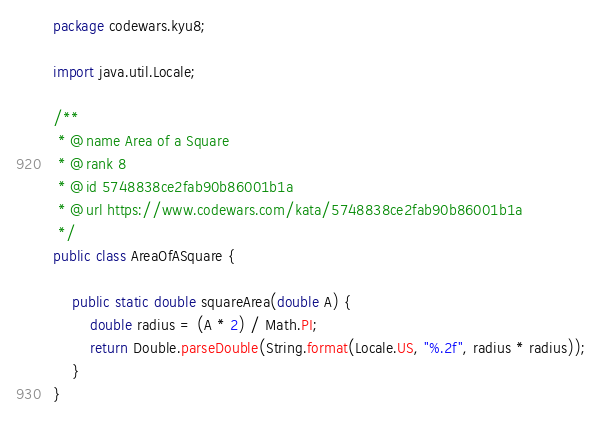<code> <loc_0><loc_0><loc_500><loc_500><_Java_>package codewars.kyu8;

import java.util.Locale;

/**
 * @name Area of a Square
 * @rank 8
 * @id 5748838ce2fab90b86001b1a
 * @url https://www.codewars.com/kata/5748838ce2fab90b86001b1a
 */
public class AreaOfASquare {

    public static double squareArea(double A) {
        double radius = (A * 2) / Math.PI;
        return Double.parseDouble(String.format(Locale.US, "%.2f", radius * radius));
    }
}
</code> 